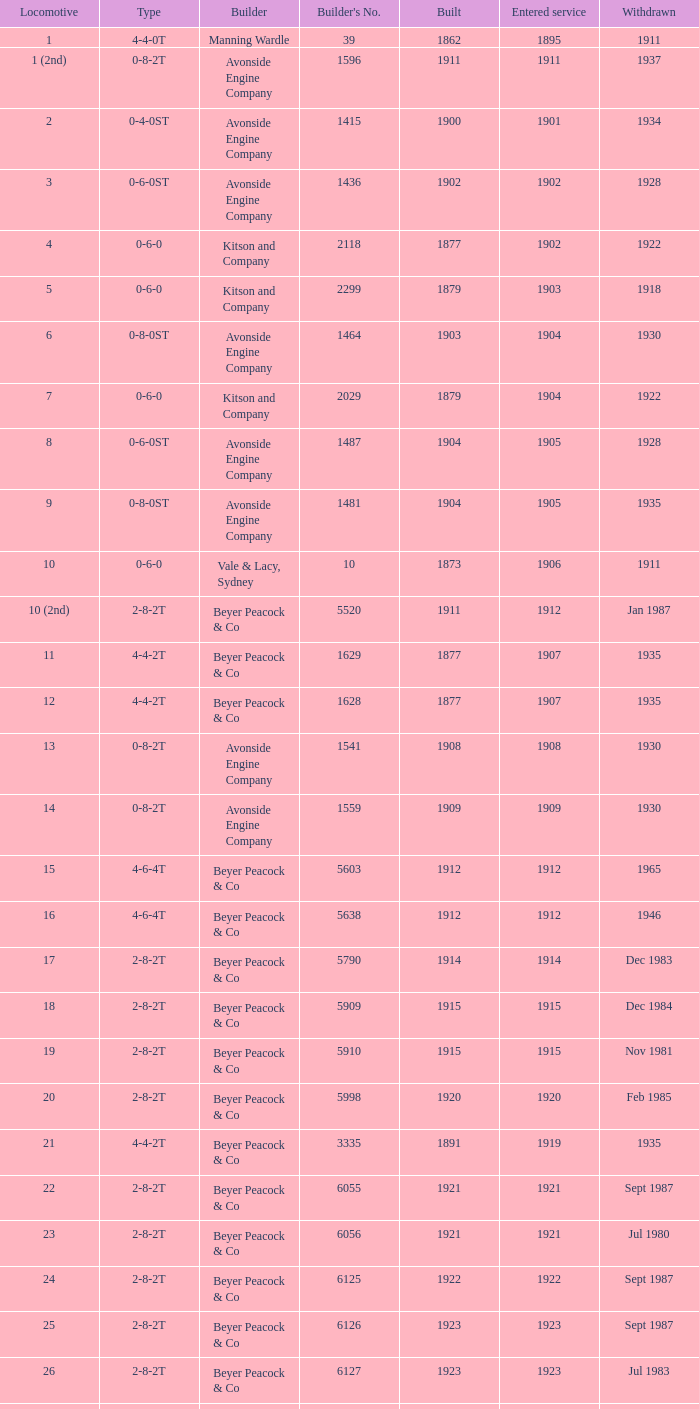Which 2-8-2t type train, started operating before 1915, and was assembled after 1911? 17.0. 